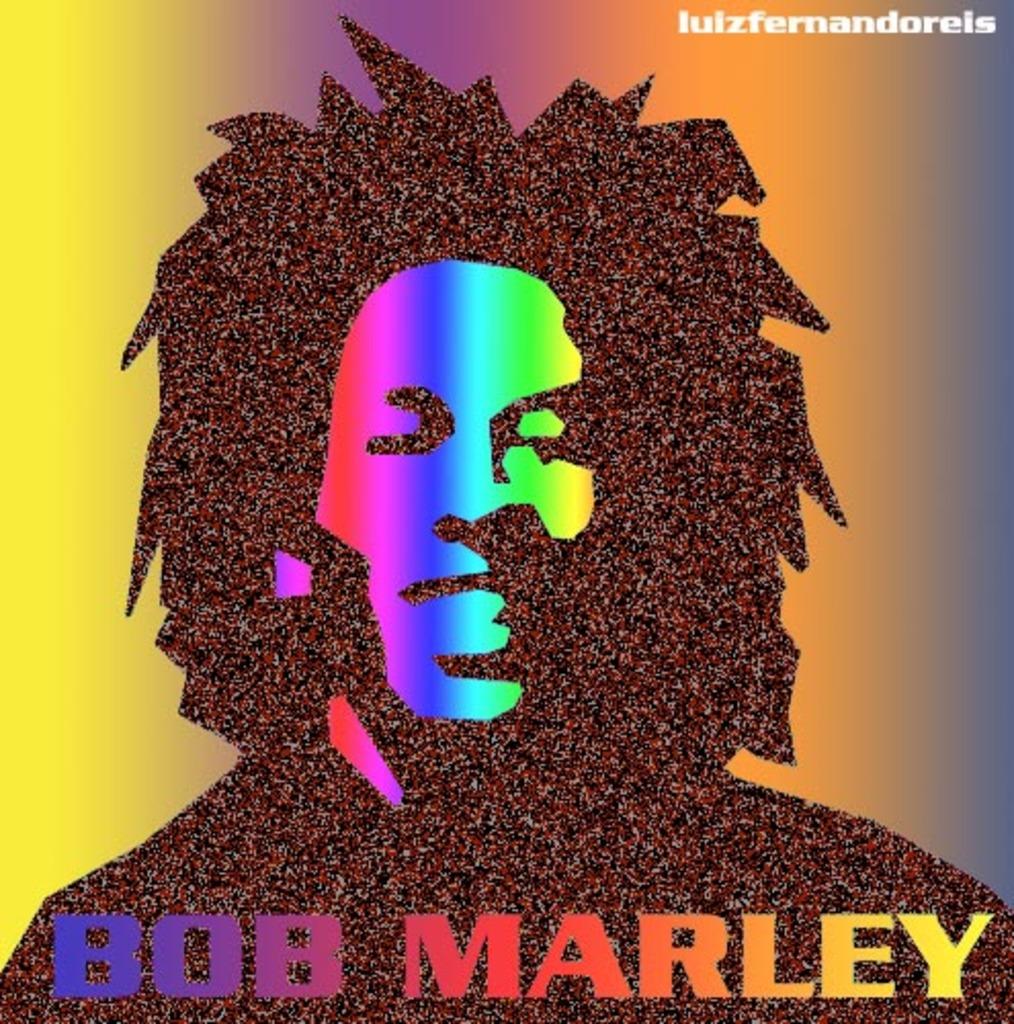Who is this?
Provide a short and direct response. Bob marley. Who was the artist of this poster, seen on the top right?
Offer a very short reply. Lulzfernandoreis. 